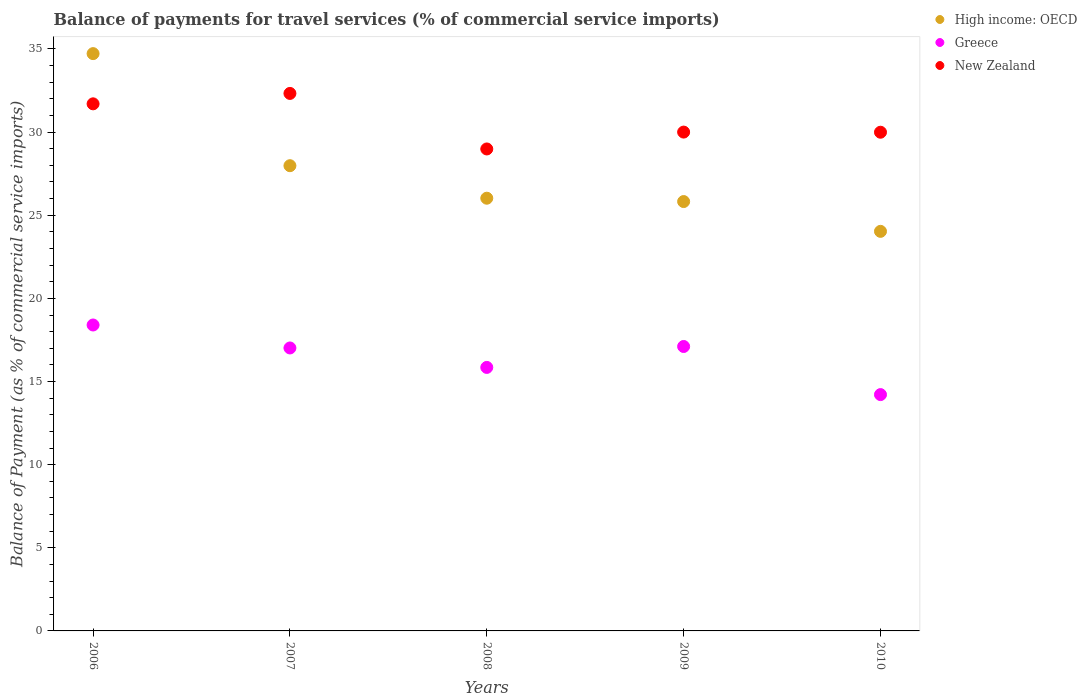How many different coloured dotlines are there?
Your answer should be compact. 3. Is the number of dotlines equal to the number of legend labels?
Provide a short and direct response. Yes. What is the balance of payments for travel services in Greece in 2009?
Make the answer very short. 17.11. Across all years, what is the maximum balance of payments for travel services in New Zealand?
Provide a short and direct response. 32.33. Across all years, what is the minimum balance of payments for travel services in New Zealand?
Your answer should be compact. 28.99. In which year was the balance of payments for travel services in High income: OECD minimum?
Make the answer very short. 2010. What is the total balance of payments for travel services in Greece in the graph?
Give a very brief answer. 82.58. What is the difference between the balance of payments for travel services in New Zealand in 2008 and that in 2010?
Keep it short and to the point. -1.01. What is the difference between the balance of payments for travel services in New Zealand in 2006 and the balance of payments for travel services in High income: OECD in 2009?
Keep it short and to the point. 5.88. What is the average balance of payments for travel services in New Zealand per year?
Provide a succinct answer. 30.6. In the year 2010, what is the difference between the balance of payments for travel services in Greece and balance of payments for travel services in New Zealand?
Your answer should be very brief. -15.78. What is the ratio of the balance of payments for travel services in High income: OECD in 2007 to that in 2009?
Provide a succinct answer. 1.08. Is the balance of payments for travel services in New Zealand in 2006 less than that in 2008?
Keep it short and to the point. No. Is the difference between the balance of payments for travel services in Greece in 2007 and 2008 greater than the difference between the balance of payments for travel services in New Zealand in 2007 and 2008?
Your answer should be compact. No. What is the difference between the highest and the second highest balance of payments for travel services in New Zealand?
Provide a succinct answer. 0.63. What is the difference between the highest and the lowest balance of payments for travel services in High income: OECD?
Give a very brief answer. 10.69. In how many years, is the balance of payments for travel services in New Zealand greater than the average balance of payments for travel services in New Zealand taken over all years?
Your answer should be compact. 2. Is the balance of payments for travel services in High income: OECD strictly less than the balance of payments for travel services in Greece over the years?
Your response must be concise. No. What is the difference between two consecutive major ticks on the Y-axis?
Provide a succinct answer. 5. Where does the legend appear in the graph?
Your answer should be compact. Top right. How many legend labels are there?
Make the answer very short. 3. How are the legend labels stacked?
Give a very brief answer. Vertical. What is the title of the graph?
Provide a succinct answer. Balance of payments for travel services (% of commercial service imports). Does "Pakistan" appear as one of the legend labels in the graph?
Make the answer very short. No. What is the label or title of the Y-axis?
Provide a succinct answer. Balance of Payment (as % of commercial service imports). What is the Balance of Payment (as % of commercial service imports) of High income: OECD in 2006?
Your answer should be compact. 34.72. What is the Balance of Payment (as % of commercial service imports) of Greece in 2006?
Offer a terse response. 18.4. What is the Balance of Payment (as % of commercial service imports) in New Zealand in 2006?
Provide a short and direct response. 31.7. What is the Balance of Payment (as % of commercial service imports) of High income: OECD in 2007?
Offer a terse response. 27.98. What is the Balance of Payment (as % of commercial service imports) in Greece in 2007?
Your response must be concise. 17.02. What is the Balance of Payment (as % of commercial service imports) in New Zealand in 2007?
Your response must be concise. 32.33. What is the Balance of Payment (as % of commercial service imports) of High income: OECD in 2008?
Your answer should be very brief. 26.02. What is the Balance of Payment (as % of commercial service imports) of Greece in 2008?
Your answer should be compact. 15.85. What is the Balance of Payment (as % of commercial service imports) of New Zealand in 2008?
Ensure brevity in your answer.  28.99. What is the Balance of Payment (as % of commercial service imports) in High income: OECD in 2009?
Your answer should be very brief. 25.82. What is the Balance of Payment (as % of commercial service imports) of Greece in 2009?
Offer a very short reply. 17.11. What is the Balance of Payment (as % of commercial service imports) of New Zealand in 2009?
Make the answer very short. 30. What is the Balance of Payment (as % of commercial service imports) of High income: OECD in 2010?
Ensure brevity in your answer.  24.03. What is the Balance of Payment (as % of commercial service imports) of Greece in 2010?
Offer a very short reply. 14.21. What is the Balance of Payment (as % of commercial service imports) of New Zealand in 2010?
Offer a very short reply. 29.99. Across all years, what is the maximum Balance of Payment (as % of commercial service imports) of High income: OECD?
Your answer should be compact. 34.72. Across all years, what is the maximum Balance of Payment (as % of commercial service imports) in Greece?
Your response must be concise. 18.4. Across all years, what is the maximum Balance of Payment (as % of commercial service imports) in New Zealand?
Give a very brief answer. 32.33. Across all years, what is the minimum Balance of Payment (as % of commercial service imports) of High income: OECD?
Give a very brief answer. 24.03. Across all years, what is the minimum Balance of Payment (as % of commercial service imports) in Greece?
Keep it short and to the point. 14.21. Across all years, what is the minimum Balance of Payment (as % of commercial service imports) of New Zealand?
Your answer should be compact. 28.99. What is the total Balance of Payment (as % of commercial service imports) of High income: OECD in the graph?
Give a very brief answer. 138.58. What is the total Balance of Payment (as % of commercial service imports) in Greece in the graph?
Give a very brief answer. 82.58. What is the total Balance of Payment (as % of commercial service imports) of New Zealand in the graph?
Keep it short and to the point. 153. What is the difference between the Balance of Payment (as % of commercial service imports) of High income: OECD in 2006 and that in 2007?
Give a very brief answer. 6.74. What is the difference between the Balance of Payment (as % of commercial service imports) of Greece in 2006 and that in 2007?
Provide a short and direct response. 1.38. What is the difference between the Balance of Payment (as % of commercial service imports) of New Zealand in 2006 and that in 2007?
Provide a short and direct response. -0.63. What is the difference between the Balance of Payment (as % of commercial service imports) of High income: OECD in 2006 and that in 2008?
Your answer should be compact. 8.7. What is the difference between the Balance of Payment (as % of commercial service imports) in Greece in 2006 and that in 2008?
Offer a terse response. 2.55. What is the difference between the Balance of Payment (as % of commercial service imports) of New Zealand in 2006 and that in 2008?
Ensure brevity in your answer.  2.71. What is the difference between the Balance of Payment (as % of commercial service imports) of High income: OECD in 2006 and that in 2009?
Your response must be concise. 8.9. What is the difference between the Balance of Payment (as % of commercial service imports) of Greece in 2006 and that in 2009?
Keep it short and to the point. 1.29. What is the difference between the Balance of Payment (as % of commercial service imports) in New Zealand in 2006 and that in 2009?
Provide a succinct answer. 1.7. What is the difference between the Balance of Payment (as % of commercial service imports) in High income: OECD in 2006 and that in 2010?
Provide a succinct answer. 10.69. What is the difference between the Balance of Payment (as % of commercial service imports) of Greece in 2006 and that in 2010?
Give a very brief answer. 4.19. What is the difference between the Balance of Payment (as % of commercial service imports) in New Zealand in 2006 and that in 2010?
Your response must be concise. 1.71. What is the difference between the Balance of Payment (as % of commercial service imports) in High income: OECD in 2007 and that in 2008?
Your response must be concise. 1.96. What is the difference between the Balance of Payment (as % of commercial service imports) of Greece in 2007 and that in 2008?
Provide a short and direct response. 1.17. What is the difference between the Balance of Payment (as % of commercial service imports) in New Zealand in 2007 and that in 2008?
Your answer should be compact. 3.34. What is the difference between the Balance of Payment (as % of commercial service imports) in High income: OECD in 2007 and that in 2009?
Provide a short and direct response. 2.16. What is the difference between the Balance of Payment (as % of commercial service imports) in Greece in 2007 and that in 2009?
Your response must be concise. -0.09. What is the difference between the Balance of Payment (as % of commercial service imports) of New Zealand in 2007 and that in 2009?
Your response must be concise. 2.33. What is the difference between the Balance of Payment (as % of commercial service imports) in High income: OECD in 2007 and that in 2010?
Provide a succinct answer. 3.95. What is the difference between the Balance of Payment (as % of commercial service imports) of Greece in 2007 and that in 2010?
Offer a very short reply. 2.81. What is the difference between the Balance of Payment (as % of commercial service imports) of New Zealand in 2007 and that in 2010?
Offer a very short reply. 2.33. What is the difference between the Balance of Payment (as % of commercial service imports) in High income: OECD in 2008 and that in 2009?
Offer a very short reply. 0.2. What is the difference between the Balance of Payment (as % of commercial service imports) in Greece in 2008 and that in 2009?
Offer a very short reply. -1.26. What is the difference between the Balance of Payment (as % of commercial service imports) of New Zealand in 2008 and that in 2009?
Provide a short and direct response. -1.01. What is the difference between the Balance of Payment (as % of commercial service imports) in High income: OECD in 2008 and that in 2010?
Offer a terse response. 1.99. What is the difference between the Balance of Payment (as % of commercial service imports) in Greece in 2008 and that in 2010?
Give a very brief answer. 1.64. What is the difference between the Balance of Payment (as % of commercial service imports) of New Zealand in 2008 and that in 2010?
Your answer should be very brief. -1.01. What is the difference between the Balance of Payment (as % of commercial service imports) of High income: OECD in 2009 and that in 2010?
Keep it short and to the point. 1.79. What is the difference between the Balance of Payment (as % of commercial service imports) of Greece in 2009 and that in 2010?
Your response must be concise. 2.89. What is the difference between the Balance of Payment (as % of commercial service imports) of New Zealand in 2009 and that in 2010?
Keep it short and to the point. 0.01. What is the difference between the Balance of Payment (as % of commercial service imports) in High income: OECD in 2006 and the Balance of Payment (as % of commercial service imports) in Greece in 2007?
Give a very brief answer. 17.7. What is the difference between the Balance of Payment (as % of commercial service imports) of High income: OECD in 2006 and the Balance of Payment (as % of commercial service imports) of New Zealand in 2007?
Keep it short and to the point. 2.39. What is the difference between the Balance of Payment (as % of commercial service imports) in Greece in 2006 and the Balance of Payment (as % of commercial service imports) in New Zealand in 2007?
Your answer should be compact. -13.93. What is the difference between the Balance of Payment (as % of commercial service imports) in High income: OECD in 2006 and the Balance of Payment (as % of commercial service imports) in Greece in 2008?
Your answer should be compact. 18.87. What is the difference between the Balance of Payment (as % of commercial service imports) of High income: OECD in 2006 and the Balance of Payment (as % of commercial service imports) of New Zealand in 2008?
Make the answer very short. 5.73. What is the difference between the Balance of Payment (as % of commercial service imports) of Greece in 2006 and the Balance of Payment (as % of commercial service imports) of New Zealand in 2008?
Make the answer very short. -10.59. What is the difference between the Balance of Payment (as % of commercial service imports) in High income: OECD in 2006 and the Balance of Payment (as % of commercial service imports) in Greece in 2009?
Keep it short and to the point. 17.61. What is the difference between the Balance of Payment (as % of commercial service imports) of High income: OECD in 2006 and the Balance of Payment (as % of commercial service imports) of New Zealand in 2009?
Keep it short and to the point. 4.72. What is the difference between the Balance of Payment (as % of commercial service imports) of Greece in 2006 and the Balance of Payment (as % of commercial service imports) of New Zealand in 2009?
Provide a succinct answer. -11.6. What is the difference between the Balance of Payment (as % of commercial service imports) of High income: OECD in 2006 and the Balance of Payment (as % of commercial service imports) of Greece in 2010?
Your response must be concise. 20.51. What is the difference between the Balance of Payment (as % of commercial service imports) of High income: OECD in 2006 and the Balance of Payment (as % of commercial service imports) of New Zealand in 2010?
Provide a succinct answer. 4.73. What is the difference between the Balance of Payment (as % of commercial service imports) of Greece in 2006 and the Balance of Payment (as % of commercial service imports) of New Zealand in 2010?
Make the answer very short. -11.59. What is the difference between the Balance of Payment (as % of commercial service imports) in High income: OECD in 2007 and the Balance of Payment (as % of commercial service imports) in Greece in 2008?
Provide a succinct answer. 12.13. What is the difference between the Balance of Payment (as % of commercial service imports) of High income: OECD in 2007 and the Balance of Payment (as % of commercial service imports) of New Zealand in 2008?
Offer a very short reply. -1.01. What is the difference between the Balance of Payment (as % of commercial service imports) in Greece in 2007 and the Balance of Payment (as % of commercial service imports) in New Zealand in 2008?
Your response must be concise. -11.97. What is the difference between the Balance of Payment (as % of commercial service imports) in High income: OECD in 2007 and the Balance of Payment (as % of commercial service imports) in Greece in 2009?
Your answer should be compact. 10.87. What is the difference between the Balance of Payment (as % of commercial service imports) of High income: OECD in 2007 and the Balance of Payment (as % of commercial service imports) of New Zealand in 2009?
Keep it short and to the point. -2.02. What is the difference between the Balance of Payment (as % of commercial service imports) of Greece in 2007 and the Balance of Payment (as % of commercial service imports) of New Zealand in 2009?
Give a very brief answer. -12.98. What is the difference between the Balance of Payment (as % of commercial service imports) in High income: OECD in 2007 and the Balance of Payment (as % of commercial service imports) in Greece in 2010?
Offer a terse response. 13.77. What is the difference between the Balance of Payment (as % of commercial service imports) in High income: OECD in 2007 and the Balance of Payment (as % of commercial service imports) in New Zealand in 2010?
Ensure brevity in your answer.  -2.01. What is the difference between the Balance of Payment (as % of commercial service imports) in Greece in 2007 and the Balance of Payment (as % of commercial service imports) in New Zealand in 2010?
Your answer should be compact. -12.97. What is the difference between the Balance of Payment (as % of commercial service imports) of High income: OECD in 2008 and the Balance of Payment (as % of commercial service imports) of Greece in 2009?
Give a very brief answer. 8.92. What is the difference between the Balance of Payment (as % of commercial service imports) in High income: OECD in 2008 and the Balance of Payment (as % of commercial service imports) in New Zealand in 2009?
Your answer should be very brief. -3.98. What is the difference between the Balance of Payment (as % of commercial service imports) in Greece in 2008 and the Balance of Payment (as % of commercial service imports) in New Zealand in 2009?
Make the answer very short. -14.15. What is the difference between the Balance of Payment (as % of commercial service imports) of High income: OECD in 2008 and the Balance of Payment (as % of commercial service imports) of Greece in 2010?
Your answer should be very brief. 11.81. What is the difference between the Balance of Payment (as % of commercial service imports) in High income: OECD in 2008 and the Balance of Payment (as % of commercial service imports) in New Zealand in 2010?
Give a very brief answer. -3.97. What is the difference between the Balance of Payment (as % of commercial service imports) of Greece in 2008 and the Balance of Payment (as % of commercial service imports) of New Zealand in 2010?
Your answer should be compact. -14.14. What is the difference between the Balance of Payment (as % of commercial service imports) of High income: OECD in 2009 and the Balance of Payment (as % of commercial service imports) of Greece in 2010?
Your response must be concise. 11.61. What is the difference between the Balance of Payment (as % of commercial service imports) in High income: OECD in 2009 and the Balance of Payment (as % of commercial service imports) in New Zealand in 2010?
Ensure brevity in your answer.  -4.17. What is the difference between the Balance of Payment (as % of commercial service imports) of Greece in 2009 and the Balance of Payment (as % of commercial service imports) of New Zealand in 2010?
Offer a terse response. -12.89. What is the average Balance of Payment (as % of commercial service imports) of High income: OECD per year?
Your answer should be compact. 27.72. What is the average Balance of Payment (as % of commercial service imports) of Greece per year?
Make the answer very short. 16.52. What is the average Balance of Payment (as % of commercial service imports) in New Zealand per year?
Provide a succinct answer. 30.6. In the year 2006, what is the difference between the Balance of Payment (as % of commercial service imports) of High income: OECD and Balance of Payment (as % of commercial service imports) of Greece?
Keep it short and to the point. 16.32. In the year 2006, what is the difference between the Balance of Payment (as % of commercial service imports) of High income: OECD and Balance of Payment (as % of commercial service imports) of New Zealand?
Give a very brief answer. 3.02. In the year 2006, what is the difference between the Balance of Payment (as % of commercial service imports) of Greece and Balance of Payment (as % of commercial service imports) of New Zealand?
Make the answer very short. -13.3. In the year 2007, what is the difference between the Balance of Payment (as % of commercial service imports) of High income: OECD and Balance of Payment (as % of commercial service imports) of Greece?
Offer a very short reply. 10.96. In the year 2007, what is the difference between the Balance of Payment (as % of commercial service imports) in High income: OECD and Balance of Payment (as % of commercial service imports) in New Zealand?
Your answer should be compact. -4.35. In the year 2007, what is the difference between the Balance of Payment (as % of commercial service imports) of Greece and Balance of Payment (as % of commercial service imports) of New Zealand?
Ensure brevity in your answer.  -15.31. In the year 2008, what is the difference between the Balance of Payment (as % of commercial service imports) in High income: OECD and Balance of Payment (as % of commercial service imports) in Greece?
Provide a short and direct response. 10.18. In the year 2008, what is the difference between the Balance of Payment (as % of commercial service imports) of High income: OECD and Balance of Payment (as % of commercial service imports) of New Zealand?
Give a very brief answer. -2.96. In the year 2008, what is the difference between the Balance of Payment (as % of commercial service imports) in Greece and Balance of Payment (as % of commercial service imports) in New Zealand?
Offer a very short reply. -13.14. In the year 2009, what is the difference between the Balance of Payment (as % of commercial service imports) in High income: OECD and Balance of Payment (as % of commercial service imports) in Greece?
Your answer should be very brief. 8.72. In the year 2009, what is the difference between the Balance of Payment (as % of commercial service imports) in High income: OECD and Balance of Payment (as % of commercial service imports) in New Zealand?
Make the answer very short. -4.18. In the year 2009, what is the difference between the Balance of Payment (as % of commercial service imports) in Greece and Balance of Payment (as % of commercial service imports) in New Zealand?
Offer a terse response. -12.89. In the year 2010, what is the difference between the Balance of Payment (as % of commercial service imports) of High income: OECD and Balance of Payment (as % of commercial service imports) of Greece?
Your response must be concise. 9.82. In the year 2010, what is the difference between the Balance of Payment (as % of commercial service imports) in High income: OECD and Balance of Payment (as % of commercial service imports) in New Zealand?
Provide a succinct answer. -5.96. In the year 2010, what is the difference between the Balance of Payment (as % of commercial service imports) in Greece and Balance of Payment (as % of commercial service imports) in New Zealand?
Offer a terse response. -15.78. What is the ratio of the Balance of Payment (as % of commercial service imports) of High income: OECD in 2006 to that in 2007?
Make the answer very short. 1.24. What is the ratio of the Balance of Payment (as % of commercial service imports) of Greece in 2006 to that in 2007?
Provide a short and direct response. 1.08. What is the ratio of the Balance of Payment (as % of commercial service imports) of New Zealand in 2006 to that in 2007?
Make the answer very short. 0.98. What is the ratio of the Balance of Payment (as % of commercial service imports) of High income: OECD in 2006 to that in 2008?
Your answer should be compact. 1.33. What is the ratio of the Balance of Payment (as % of commercial service imports) of Greece in 2006 to that in 2008?
Your response must be concise. 1.16. What is the ratio of the Balance of Payment (as % of commercial service imports) of New Zealand in 2006 to that in 2008?
Your answer should be very brief. 1.09. What is the ratio of the Balance of Payment (as % of commercial service imports) of High income: OECD in 2006 to that in 2009?
Your response must be concise. 1.34. What is the ratio of the Balance of Payment (as % of commercial service imports) of Greece in 2006 to that in 2009?
Give a very brief answer. 1.08. What is the ratio of the Balance of Payment (as % of commercial service imports) in New Zealand in 2006 to that in 2009?
Give a very brief answer. 1.06. What is the ratio of the Balance of Payment (as % of commercial service imports) of High income: OECD in 2006 to that in 2010?
Give a very brief answer. 1.44. What is the ratio of the Balance of Payment (as % of commercial service imports) of Greece in 2006 to that in 2010?
Your answer should be compact. 1.29. What is the ratio of the Balance of Payment (as % of commercial service imports) in New Zealand in 2006 to that in 2010?
Your response must be concise. 1.06. What is the ratio of the Balance of Payment (as % of commercial service imports) of High income: OECD in 2007 to that in 2008?
Ensure brevity in your answer.  1.08. What is the ratio of the Balance of Payment (as % of commercial service imports) in Greece in 2007 to that in 2008?
Provide a short and direct response. 1.07. What is the ratio of the Balance of Payment (as % of commercial service imports) of New Zealand in 2007 to that in 2008?
Make the answer very short. 1.12. What is the ratio of the Balance of Payment (as % of commercial service imports) in High income: OECD in 2007 to that in 2009?
Give a very brief answer. 1.08. What is the ratio of the Balance of Payment (as % of commercial service imports) in Greece in 2007 to that in 2009?
Keep it short and to the point. 0.99. What is the ratio of the Balance of Payment (as % of commercial service imports) of New Zealand in 2007 to that in 2009?
Ensure brevity in your answer.  1.08. What is the ratio of the Balance of Payment (as % of commercial service imports) in High income: OECD in 2007 to that in 2010?
Provide a succinct answer. 1.16. What is the ratio of the Balance of Payment (as % of commercial service imports) in Greece in 2007 to that in 2010?
Offer a terse response. 1.2. What is the ratio of the Balance of Payment (as % of commercial service imports) in New Zealand in 2007 to that in 2010?
Your answer should be very brief. 1.08. What is the ratio of the Balance of Payment (as % of commercial service imports) of Greece in 2008 to that in 2009?
Provide a short and direct response. 0.93. What is the ratio of the Balance of Payment (as % of commercial service imports) of New Zealand in 2008 to that in 2009?
Ensure brevity in your answer.  0.97. What is the ratio of the Balance of Payment (as % of commercial service imports) of High income: OECD in 2008 to that in 2010?
Keep it short and to the point. 1.08. What is the ratio of the Balance of Payment (as % of commercial service imports) in Greece in 2008 to that in 2010?
Your answer should be compact. 1.12. What is the ratio of the Balance of Payment (as % of commercial service imports) in New Zealand in 2008 to that in 2010?
Provide a succinct answer. 0.97. What is the ratio of the Balance of Payment (as % of commercial service imports) of High income: OECD in 2009 to that in 2010?
Offer a terse response. 1.07. What is the ratio of the Balance of Payment (as % of commercial service imports) of Greece in 2009 to that in 2010?
Offer a terse response. 1.2. What is the ratio of the Balance of Payment (as % of commercial service imports) in New Zealand in 2009 to that in 2010?
Your answer should be very brief. 1. What is the difference between the highest and the second highest Balance of Payment (as % of commercial service imports) in High income: OECD?
Give a very brief answer. 6.74. What is the difference between the highest and the second highest Balance of Payment (as % of commercial service imports) in Greece?
Offer a very short reply. 1.29. What is the difference between the highest and the second highest Balance of Payment (as % of commercial service imports) of New Zealand?
Make the answer very short. 0.63. What is the difference between the highest and the lowest Balance of Payment (as % of commercial service imports) of High income: OECD?
Provide a succinct answer. 10.69. What is the difference between the highest and the lowest Balance of Payment (as % of commercial service imports) of Greece?
Offer a very short reply. 4.19. What is the difference between the highest and the lowest Balance of Payment (as % of commercial service imports) in New Zealand?
Ensure brevity in your answer.  3.34. 